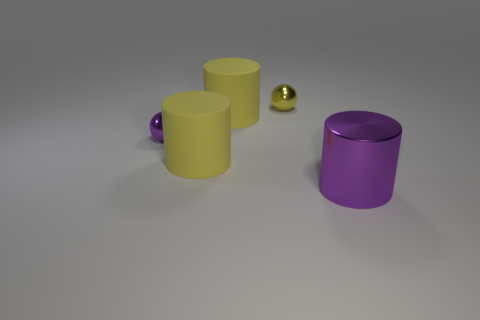Add 3 rubber things. How many objects exist? 8 Subtract all cylinders. How many objects are left? 2 Subtract all large purple metallic cylinders. Subtract all big yellow cylinders. How many objects are left? 2 Add 2 big yellow objects. How many big yellow objects are left? 4 Add 4 spheres. How many spheres exist? 6 Subtract 0 red balls. How many objects are left? 5 